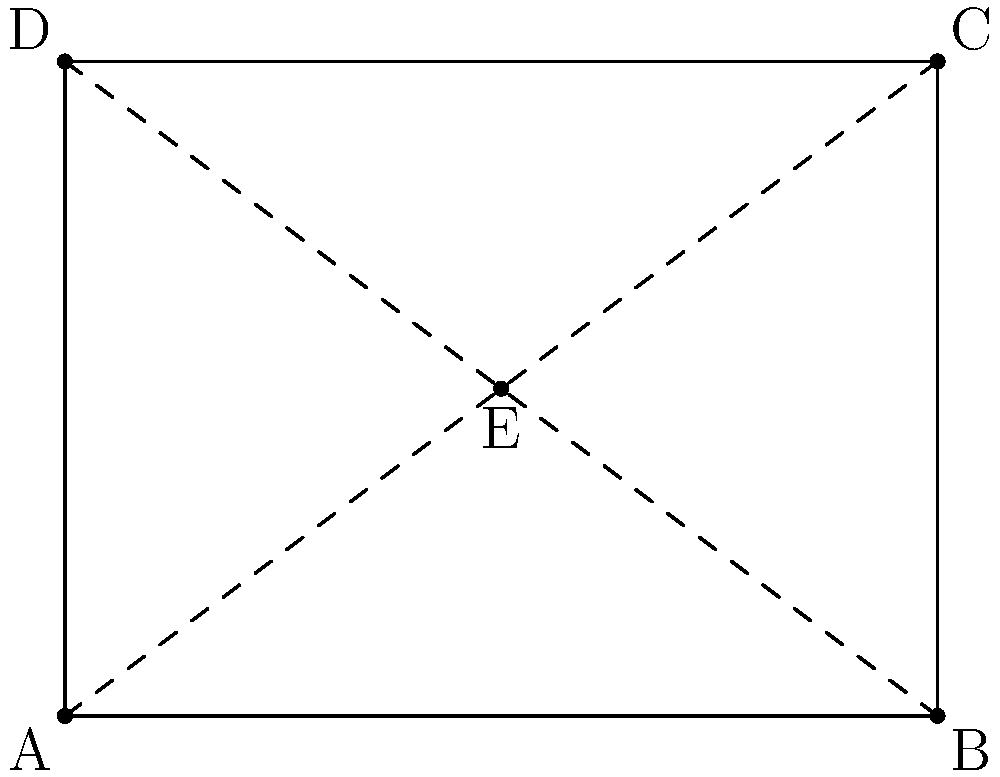In the diagram above, point E is located at the intersection of the diagonals of rectangle ABCD. If the coordinates of point A are (0,0) and the coordinates of point C are (4,3), what are the coordinates of point E? To find the coordinates of point E, we can follow these steps:

1. Identify the coordinates of the vertices:
   A (0,0), B (4,0), C (4,3), D (0,3)

2. Recognize that point E is at the intersection of the diagonals AC and BD.

3. The diagonals of a rectangle bisect each other, meaning E is the midpoint of both AC and BD.

4. To find the midpoint, we can use the midpoint formula:
   $$(x, y) = (\frac{x_1 + x_2}{2}, \frac{y_1 + y_2}{2})$$

5. Using the coordinates of A and C:
   $x = \frac{0 + 4}{2} = 2$
   $y = \frac{0 + 3}{2} = 1.5$

6. Therefore, the coordinates of point E are (2, 1.5).

This approach utilizes spatial reasoning to understand the properties of rectangles and their diagonals, which is relevant to organizing conference layouts and understanding spatial relationships in interdisciplinary contexts.
Answer: (2, 1.5) 